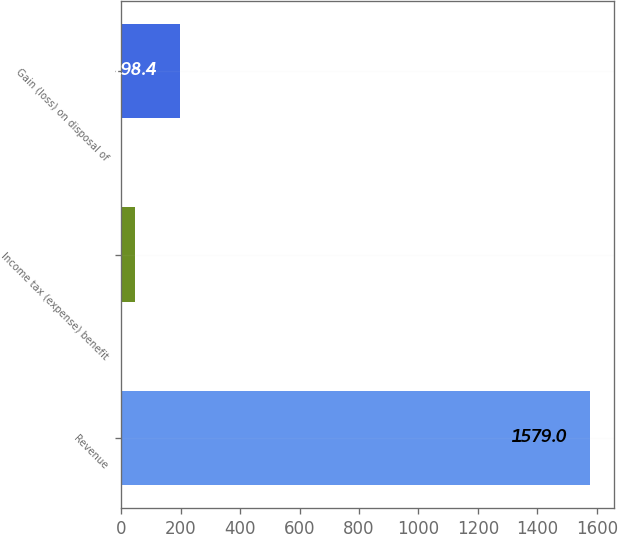Convert chart. <chart><loc_0><loc_0><loc_500><loc_500><bar_chart><fcel>Revenue<fcel>Income tax (expense) benefit<fcel>Gain (loss) on disposal of<nl><fcel>1579<fcel>45<fcel>198.4<nl></chart> 